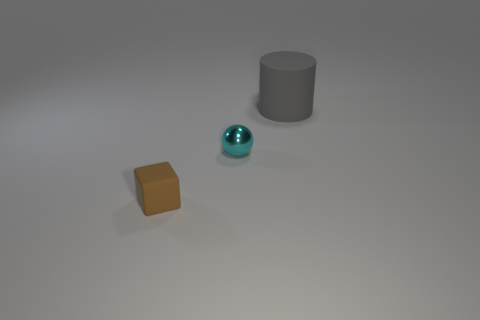What could be the function of the tiny cyan object? Given its size and isolated context, the tiny cyan object may not serve any practical function. It appears decorative, potentially an art piece or a part of a larger set meant for display. 